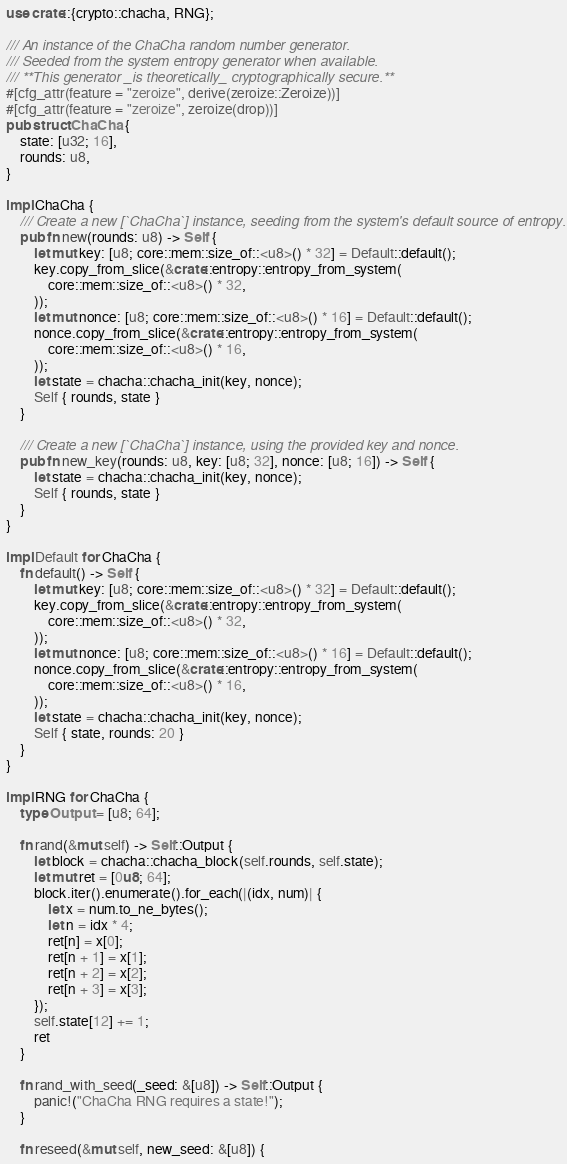Convert code to text. <code><loc_0><loc_0><loc_500><loc_500><_Rust_>use crate::{crypto::chacha, RNG};

/// An instance of the ChaCha random number generator.  
/// Seeded from the system entropy generator when available.  
/// **This generator _is theoretically_ cryptographically secure.**
#[cfg_attr(feature = "zeroize", derive(zeroize::Zeroize))]
#[cfg_attr(feature = "zeroize", zeroize(drop))]
pub struct ChaCha {
	state: [u32; 16],
	rounds: u8,
}

impl ChaCha {
	/// Create a new [`ChaCha`] instance, seeding from the system's default source of entropy.
	pub fn new(rounds: u8) -> Self {
		let mut key: [u8; core::mem::size_of::<u8>() * 32] = Default::default();
		key.copy_from_slice(&crate::entropy::entropy_from_system(
			core::mem::size_of::<u8>() * 32,
		));
		let mut nonce: [u8; core::mem::size_of::<u8>() * 16] = Default::default();
		nonce.copy_from_slice(&crate::entropy::entropy_from_system(
			core::mem::size_of::<u8>() * 16,
		));
		let state = chacha::chacha_init(key, nonce);
		Self { rounds, state }
	}

	/// Create a new [`ChaCha`] instance, using the provided key and nonce.
	pub fn new_key(rounds: u8, key: [u8; 32], nonce: [u8; 16]) -> Self {
		let state = chacha::chacha_init(key, nonce);
		Self { rounds, state }
	}
}

impl Default for ChaCha {
	fn default() -> Self {
		let mut key: [u8; core::mem::size_of::<u8>() * 32] = Default::default();
		key.copy_from_slice(&crate::entropy::entropy_from_system(
			core::mem::size_of::<u8>() * 32,
		));
		let mut nonce: [u8; core::mem::size_of::<u8>() * 16] = Default::default();
		nonce.copy_from_slice(&crate::entropy::entropy_from_system(
			core::mem::size_of::<u8>() * 16,
		));
		let state = chacha::chacha_init(key, nonce);
		Self { state, rounds: 20 }
	}
}

impl RNG for ChaCha {
	type Output = [u8; 64];

	fn rand(&mut self) -> Self::Output {
		let block = chacha::chacha_block(self.rounds, self.state);
		let mut ret = [0u8; 64];
		block.iter().enumerate().for_each(|(idx, num)| {
			let x = num.to_ne_bytes();
			let n = idx * 4;
			ret[n] = x[0];
			ret[n + 1] = x[1];
			ret[n + 2] = x[2];
			ret[n + 3] = x[3];
		});
		self.state[12] += 1;
		ret
	}

	fn rand_with_seed(_seed: &[u8]) -> Self::Output {
		panic!("ChaCha RNG requires a state!");
	}

	fn reseed(&mut self, new_seed: &[u8]) {</code> 